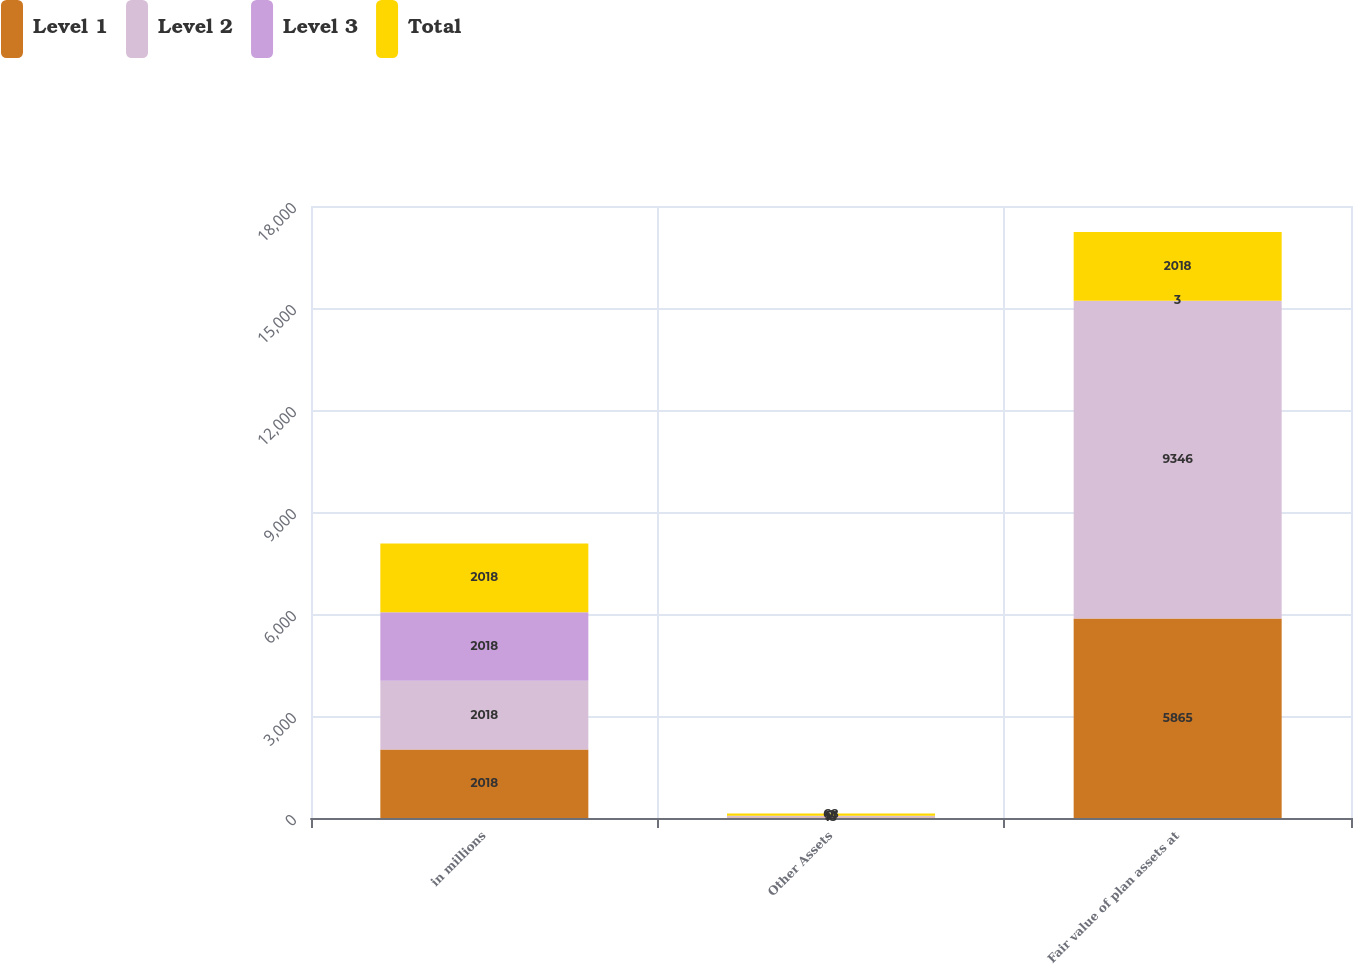<chart> <loc_0><loc_0><loc_500><loc_500><stacked_bar_chart><ecel><fcel>in millions<fcel>Other Assets<fcel>Fair value of plan assets at<nl><fcel>Level 1<fcel>2018<fcel>15<fcel>5865<nl><fcel>Level 2<fcel>2018<fcel>51<fcel>9346<nl><fcel>Level 3<fcel>2018<fcel>2<fcel>3<nl><fcel>Total<fcel>2018<fcel>68<fcel>2018<nl></chart> 